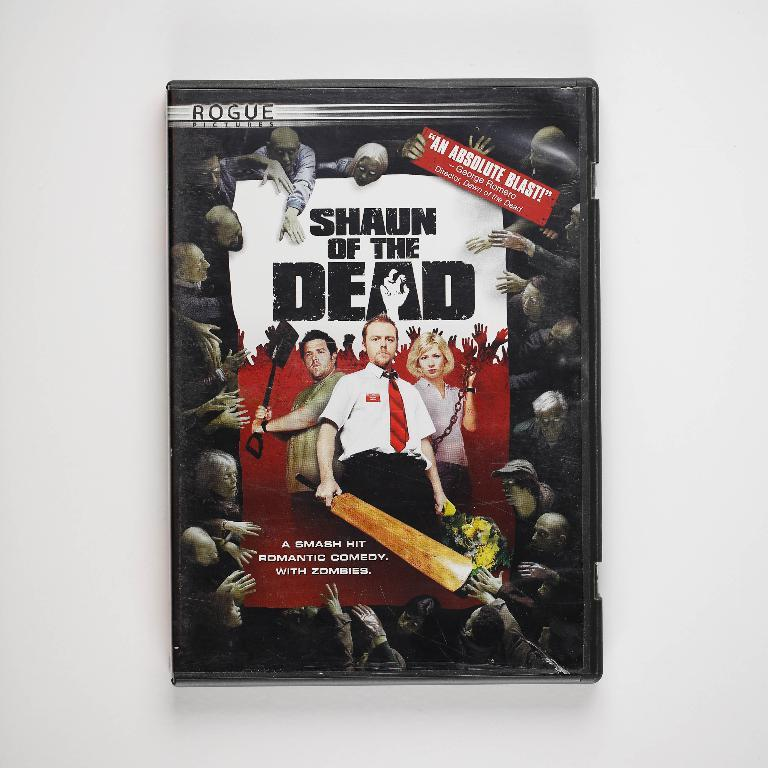Provide a one-sentence caption for the provided image. It's a DVD copy of the movie "Shaun of the dead.". 